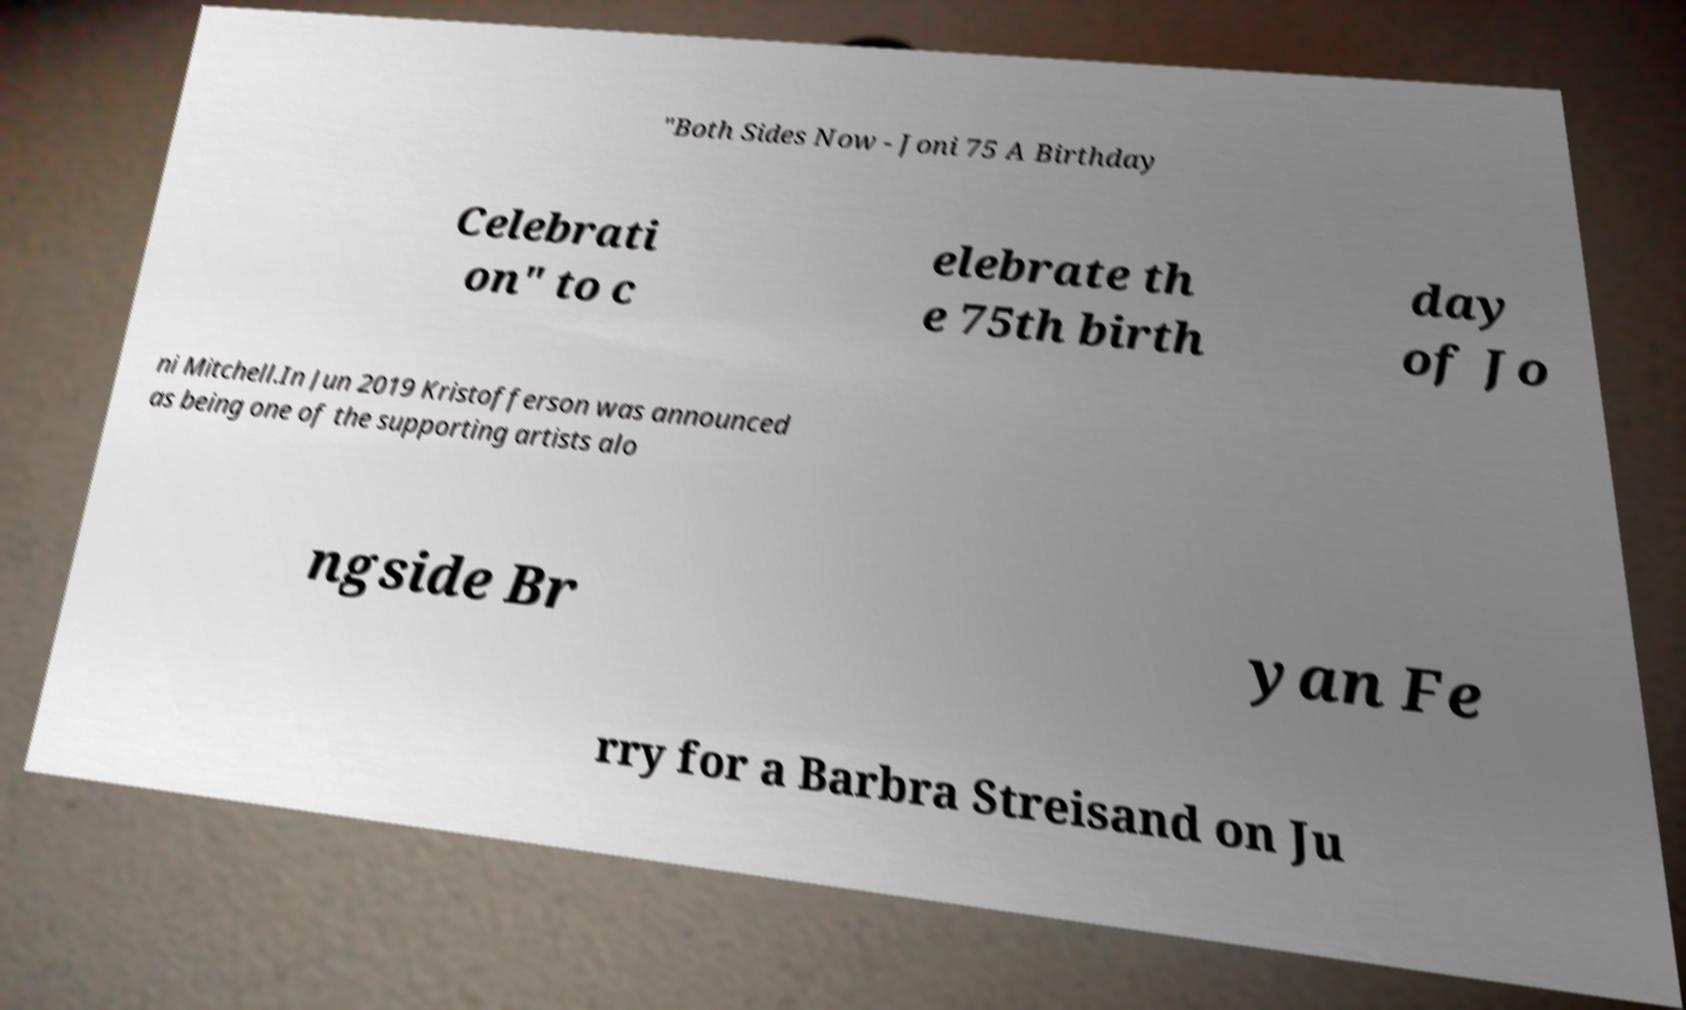For documentation purposes, I need the text within this image transcribed. Could you provide that? "Both Sides Now - Joni 75 A Birthday Celebrati on" to c elebrate th e 75th birth day of Jo ni Mitchell.In Jun 2019 Kristofferson was announced as being one of the supporting artists alo ngside Br yan Fe rry for a Barbra Streisand on Ju 